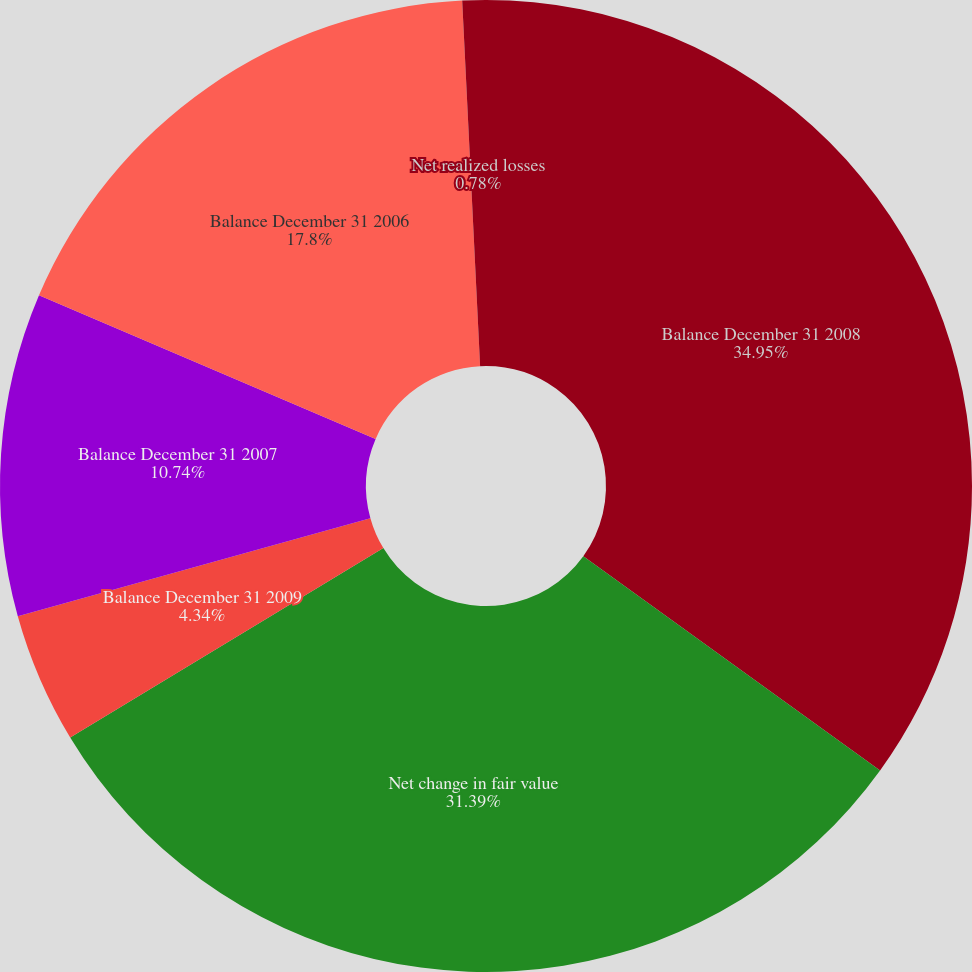Convert chart. <chart><loc_0><loc_0><loc_500><loc_500><pie_chart><fcel>Balance December 31 2008<fcel>Net change in fair value<fcel>Balance December 31 2009<fcel>Balance December 31 2007<fcel>Balance December 31 2006<fcel>Net realized losses<nl><fcel>34.95%<fcel>31.39%<fcel>4.34%<fcel>10.74%<fcel>17.8%<fcel>0.78%<nl></chart> 